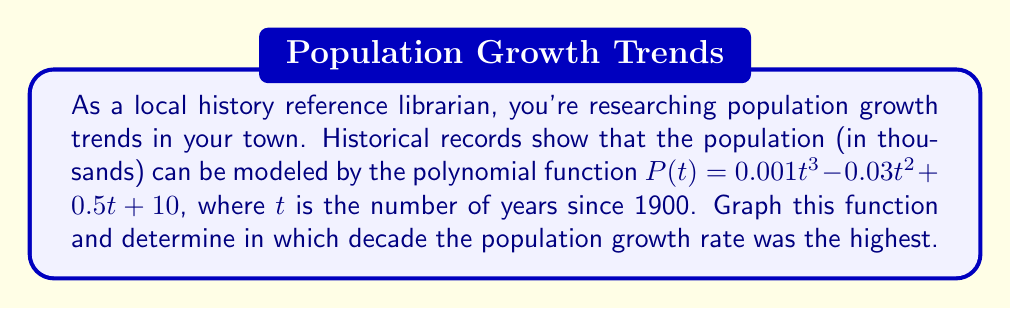Can you solve this math problem? To solve this problem, we'll follow these steps:

1) First, let's graph the polynomial function $P(t) = 0.001t^3 - 0.03t^2 + 0.5t + 10$ for $t$ from 0 to 120 (representing years 1900 to 2020).

[asy]
import graph;
size(200,200);

real f(real x) {return 0.001x^3 - 0.03x^2 + 0.5x + 10;}

draw(graph(f,0,120),blue);

xaxis("Years since 1900",Ticks());
yaxis("Population (thousands)",Ticks());
[/asy]

2) The growth rate is represented by the slope of the curve. The steepest part of the curve indicates the highest growth rate.

3) To find the decade with the highest growth rate, we need to look at the first derivative of $P(t)$, which represents the rate of change:

   $P'(t) = 0.003t^2 - 0.06t + 0.5$

4) The maximum value of $P'(t)$ within each decade will indicate the highest growth rate. Let's evaluate $P'(t)$ at the midpoint of each decade:

   1900s: $P'(5) = 0.003(5)^2 - 0.06(5) + 0.5 = 0.325$
   1910s: $P'(15) = 0.003(15)^2 - 0.06(15) + 0.5 = 0.425$
   1920s: $P'(25) = 0.003(25)^2 - 0.06(25) + 0.5 = 0.875$
   1930s: $P'(35) = 0.003(35)^2 - 0.06(35) + 0.5 = 1.675$
   1940s: $P'(45) = 0.003(45)^2 - 0.06(45) + 0.5 = 2.825$
   1950s: $P'(55) = 0.003(55)^2 - 0.06(55) + 0.5 = 4.325$
   1960s: $P'(65) = 0.003(65)^2 - 0.06(65) + 0.5 = 6.175$
   1970s: $P'(75) = 0.003(75)^2 - 0.06(75) + 0.5 = 8.375$
   1980s: $P'(85) = 0.003(85)^2 - 0.06(85) + 0.5 = 10.925$
   1990s: $P'(95) = 0.003(95)^2 - 0.06(95) + 0.5 = 13.825$
   2000s: $P'(105) = 0.003(105)^2 - 0.06(105) + 0.5 = 17.075$
   2010s: $P'(115) = 0.003(115)^2 - 0.06(115) + 0.5 = 20.675$

5) The highest value is in the 2010s, indicating this decade had the highest growth rate.
Answer: 2010s 